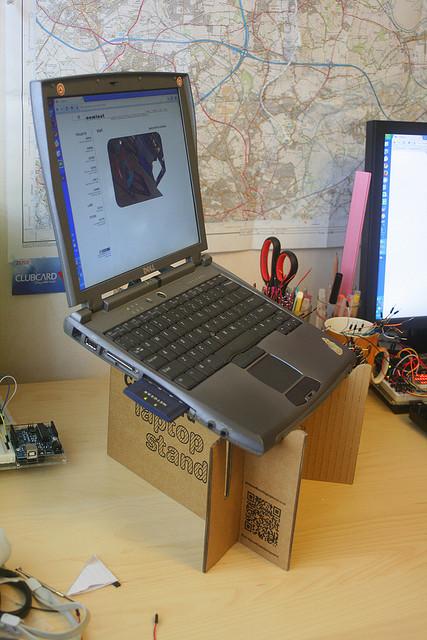What is pink in the picture?
Answer briefly. Ruler. What is on the computer screen?
Quick response, please. Picture. What is the laptop sitting on?
Be succinct. Box. 